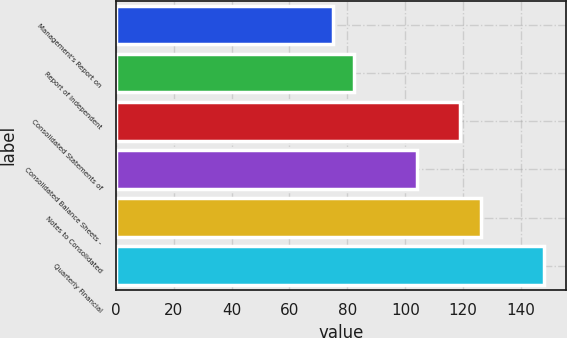<chart> <loc_0><loc_0><loc_500><loc_500><bar_chart><fcel>Management's Report on<fcel>Report of Independent<fcel>Consolidated Statements of<fcel>Consolidated Balance Sheets -<fcel>Notes to Consolidated<fcel>Quarterly Financial<nl><fcel>75<fcel>82.3<fcel>118.8<fcel>104.2<fcel>126.1<fcel>148<nl></chart> 